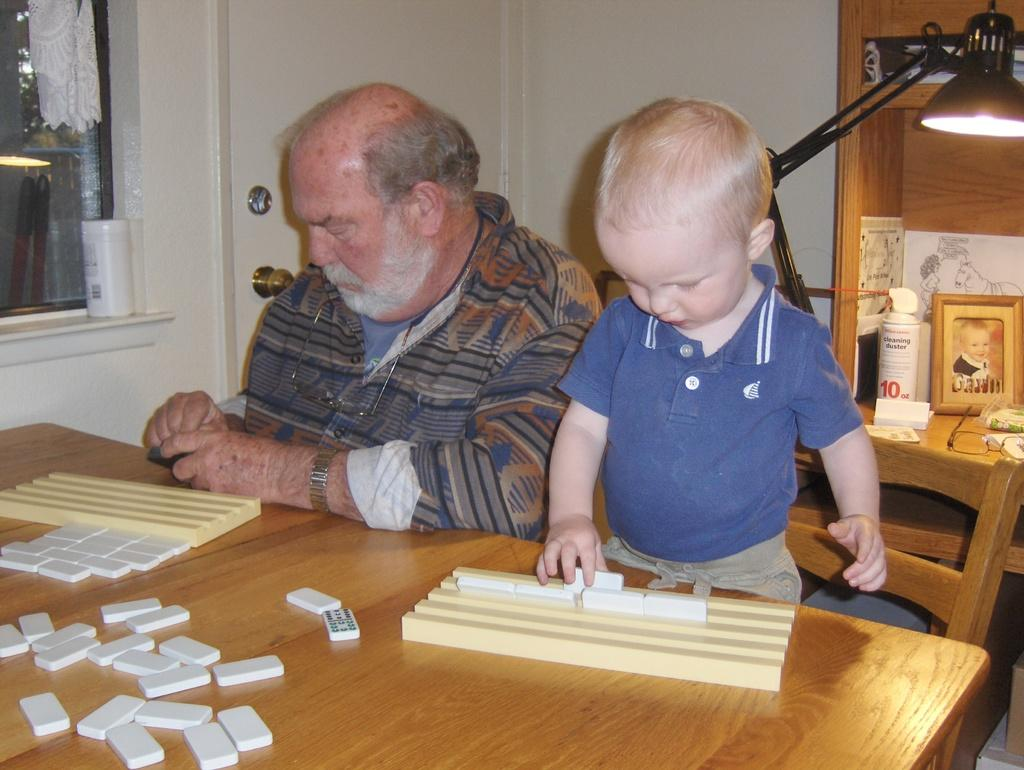What is the old man doing in the image? The old man is sitting on a chair in the image. What is the kid doing in relation to the chair? The kid is standing on the chair in the image. What objects can be seen on the table? There are puzzle blocks on the table in the image. What can be seen in the background of the image? There is a lamp, a photo frame, a door, and a window in the background of the image. How is the distribution of cars in the image? There are no cars present in the image. What type of scarf is the old man wearing in the image? The old man is not wearing a scarf in the image. 